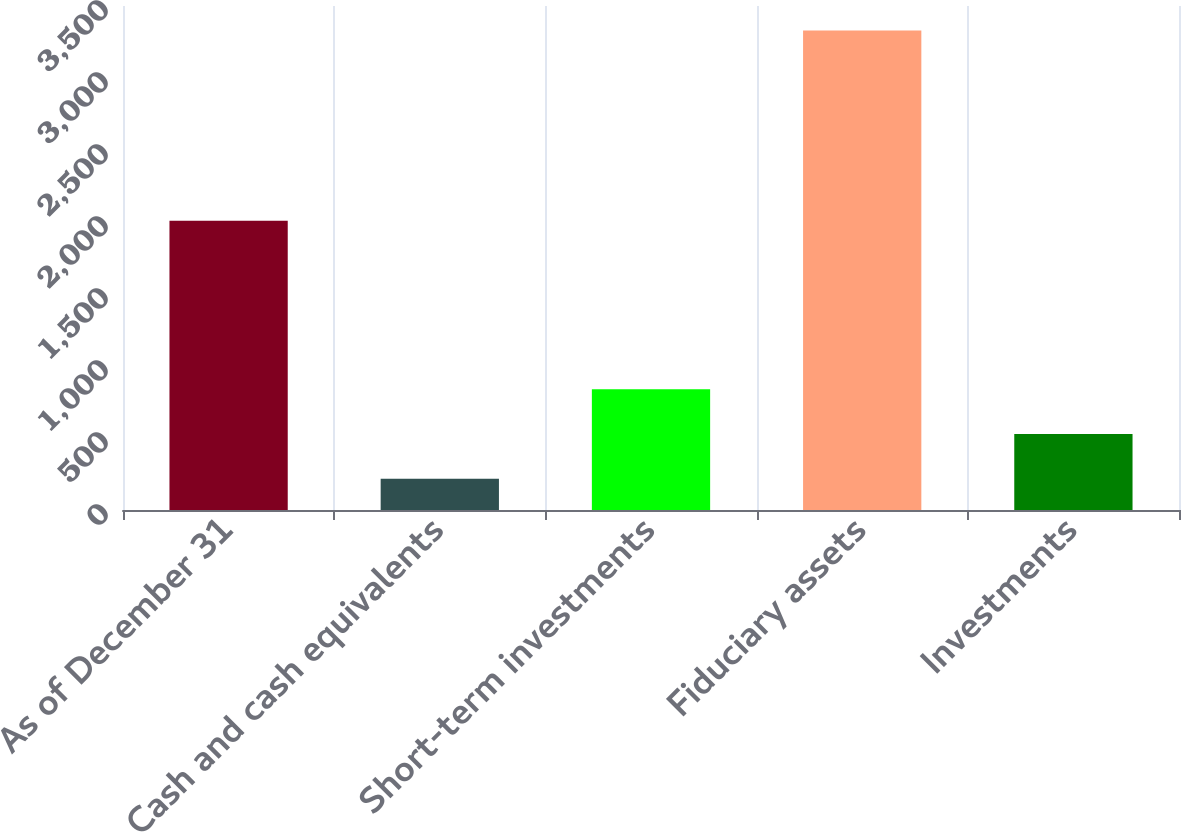Convert chart to OTSL. <chart><loc_0><loc_0><loc_500><loc_500><bar_chart><fcel>As of December 31<fcel>Cash and cash equivalents<fcel>Short-term investments<fcel>Fiduciary assets<fcel>Investments<nl><fcel>2009<fcel>217<fcel>839.4<fcel>3329<fcel>528.2<nl></chart> 